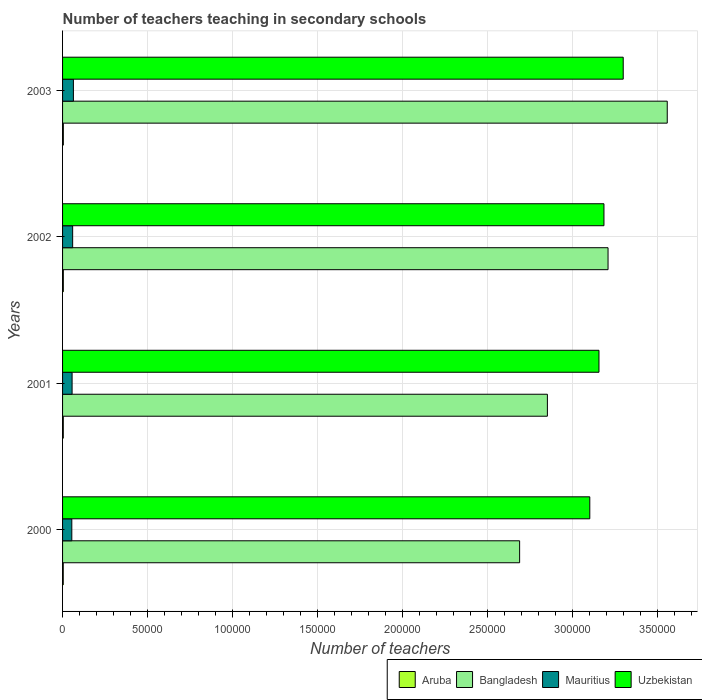How many different coloured bars are there?
Offer a terse response. 4. What is the number of teachers teaching in secondary schools in Bangladesh in 2001?
Offer a very short reply. 2.85e+05. Across all years, what is the maximum number of teachers teaching in secondary schools in Uzbekistan?
Make the answer very short. 3.30e+05. Across all years, what is the minimum number of teachers teaching in secondary schools in Bangladesh?
Your response must be concise. 2.69e+05. What is the total number of teachers teaching in secondary schools in Mauritius in the graph?
Provide a succinct answer. 2.33e+04. What is the difference between the number of teachers teaching in secondary schools in Mauritius in 2000 and that in 2001?
Keep it short and to the point. -171. What is the difference between the number of teachers teaching in secondary schools in Mauritius in 2000 and the number of teachers teaching in secondary schools in Uzbekistan in 2001?
Your response must be concise. -3.10e+05. What is the average number of teachers teaching in secondary schools in Bangladesh per year?
Make the answer very short. 3.08e+05. In the year 2002, what is the difference between the number of teachers teaching in secondary schools in Uzbekistan and number of teachers teaching in secondary schools in Bangladesh?
Provide a succinct answer. -2413. What is the ratio of the number of teachers teaching in secondary schools in Bangladesh in 2000 to that in 2003?
Provide a short and direct response. 0.76. What is the difference between the highest and the second highest number of teachers teaching in secondary schools in Uzbekistan?
Your answer should be compact. 1.13e+04. What is the difference between the highest and the lowest number of teachers teaching in secondary schools in Mauritius?
Offer a terse response. 935. In how many years, is the number of teachers teaching in secondary schools in Mauritius greater than the average number of teachers teaching in secondary schools in Mauritius taken over all years?
Offer a very short reply. 2. Is the sum of the number of teachers teaching in secondary schools in Aruba in 2000 and 2001 greater than the maximum number of teachers teaching in secondary schools in Bangladesh across all years?
Offer a very short reply. No. Is it the case that in every year, the sum of the number of teachers teaching in secondary schools in Bangladesh and number of teachers teaching in secondary schools in Aruba is greater than the sum of number of teachers teaching in secondary schools in Mauritius and number of teachers teaching in secondary schools in Uzbekistan?
Provide a short and direct response. No. What does the 1st bar from the top in 2002 represents?
Your response must be concise. Uzbekistan. What does the 2nd bar from the bottom in 2000 represents?
Provide a succinct answer. Bangladesh. How many years are there in the graph?
Give a very brief answer. 4. What is the difference between two consecutive major ticks on the X-axis?
Keep it short and to the point. 5.00e+04. Are the values on the major ticks of X-axis written in scientific E-notation?
Offer a very short reply. No. Where does the legend appear in the graph?
Provide a succinct answer. Bottom right. What is the title of the graph?
Give a very brief answer. Number of teachers teaching in secondary schools. What is the label or title of the X-axis?
Your answer should be compact. Number of teachers. What is the Number of teachers in Aruba in 2000?
Offer a very short reply. 405. What is the Number of teachers in Bangladesh in 2000?
Make the answer very short. 2.69e+05. What is the Number of teachers in Mauritius in 2000?
Your answer should be very brief. 5436. What is the Number of teachers in Uzbekistan in 2000?
Your answer should be compact. 3.10e+05. What is the Number of teachers of Aruba in 2001?
Keep it short and to the point. 427. What is the Number of teachers of Bangladesh in 2001?
Offer a very short reply. 2.85e+05. What is the Number of teachers of Mauritius in 2001?
Keep it short and to the point. 5607. What is the Number of teachers in Uzbekistan in 2001?
Provide a succinct answer. 3.15e+05. What is the Number of teachers in Aruba in 2002?
Your response must be concise. 449. What is the Number of teachers in Bangladesh in 2002?
Provide a succinct answer. 3.21e+05. What is the Number of teachers of Mauritius in 2002?
Make the answer very short. 5933. What is the Number of teachers in Uzbekistan in 2002?
Make the answer very short. 3.18e+05. What is the Number of teachers in Aruba in 2003?
Offer a very short reply. 461. What is the Number of teachers of Bangladesh in 2003?
Your response must be concise. 3.56e+05. What is the Number of teachers of Mauritius in 2003?
Offer a very short reply. 6371. What is the Number of teachers of Uzbekistan in 2003?
Your answer should be very brief. 3.30e+05. Across all years, what is the maximum Number of teachers of Aruba?
Offer a very short reply. 461. Across all years, what is the maximum Number of teachers in Bangladesh?
Your answer should be very brief. 3.56e+05. Across all years, what is the maximum Number of teachers of Mauritius?
Give a very brief answer. 6371. Across all years, what is the maximum Number of teachers in Uzbekistan?
Keep it short and to the point. 3.30e+05. Across all years, what is the minimum Number of teachers of Aruba?
Offer a terse response. 405. Across all years, what is the minimum Number of teachers of Bangladesh?
Your answer should be compact. 2.69e+05. Across all years, what is the minimum Number of teachers of Mauritius?
Offer a terse response. 5436. Across all years, what is the minimum Number of teachers in Uzbekistan?
Make the answer very short. 3.10e+05. What is the total Number of teachers of Aruba in the graph?
Ensure brevity in your answer.  1742. What is the total Number of teachers of Bangladesh in the graph?
Keep it short and to the point. 1.23e+06. What is the total Number of teachers of Mauritius in the graph?
Ensure brevity in your answer.  2.33e+04. What is the total Number of teachers in Uzbekistan in the graph?
Ensure brevity in your answer.  1.27e+06. What is the difference between the Number of teachers of Aruba in 2000 and that in 2001?
Offer a terse response. -22. What is the difference between the Number of teachers in Bangladesh in 2000 and that in 2001?
Offer a very short reply. -1.63e+04. What is the difference between the Number of teachers in Mauritius in 2000 and that in 2001?
Your answer should be very brief. -171. What is the difference between the Number of teachers in Uzbekistan in 2000 and that in 2001?
Ensure brevity in your answer.  -5396. What is the difference between the Number of teachers in Aruba in 2000 and that in 2002?
Your response must be concise. -44. What is the difference between the Number of teachers of Bangladesh in 2000 and that in 2002?
Provide a succinct answer. -5.20e+04. What is the difference between the Number of teachers in Mauritius in 2000 and that in 2002?
Offer a very short reply. -497. What is the difference between the Number of teachers of Uzbekistan in 2000 and that in 2002?
Your answer should be compact. -8323. What is the difference between the Number of teachers of Aruba in 2000 and that in 2003?
Give a very brief answer. -56. What is the difference between the Number of teachers of Bangladesh in 2000 and that in 2003?
Your answer should be compact. -8.68e+04. What is the difference between the Number of teachers of Mauritius in 2000 and that in 2003?
Provide a succinct answer. -935. What is the difference between the Number of teachers in Uzbekistan in 2000 and that in 2003?
Ensure brevity in your answer.  -1.96e+04. What is the difference between the Number of teachers of Bangladesh in 2001 and that in 2002?
Give a very brief answer. -3.57e+04. What is the difference between the Number of teachers of Mauritius in 2001 and that in 2002?
Provide a succinct answer. -326. What is the difference between the Number of teachers in Uzbekistan in 2001 and that in 2002?
Keep it short and to the point. -2927. What is the difference between the Number of teachers of Aruba in 2001 and that in 2003?
Provide a short and direct response. -34. What is the difference between the Number of teachers of Bangladesh in 2001 and that in 2003?
Ensure brevity in your answer.  -7.05e+04. What is the difference between the Number of teachers of Mauritius in 2001 and that in 2003?
Ensure brevity in your answer.  -764. What is the difference between the Number of teachers of Uzbekistan in 2001 and that in 2003?
Offer a very short reply. -1.43e+04. What is the difference between the Number of teachers of Bangladesh in 2002 and that in 2003?
Your answer should be compact. -3.48e+04. What is the difference between the Number of teachers of Mauritius in 2002 and that in 2003?
Offer a terse response. -438. What is the difference between the Number of teachers in Uzbekistan in 2002 and that in 2003?
Provide a short and direct response. -1.13e+04. What is the difference between the Number of teachers of Aruba in 2000 and the Number of teachers of Bangladesh in 2001?
Provide a succinct answer. -2.85e+05. What is the difference between the Number of teachers of Aruba in 2000 and the Number of teachers of Mauritius in 2001?
Give a very brief answer. -5202. What is the difference between the Number of teachers in Aruba in 2000 and the Number of teachers in Uzbekistan in 2001?
Offer a terse response. -3.15e+05. What is the difference between the Number of teachers in Bangladesh in 2000 and the Number of teachers in Mauritius in 2001?
Make the answer very short. 2.63e+05. What is the difference between the Number of teachers in Bangladesh in 2000 and the Number of teachers in Uzbekistan in 2001?
Give a very brief answer. -4.67e+04. What is the difference between the Number of teachers of Mauritius in 2000 and the Number of teachers of Uzbekistan in 2001?
Give a very brief answer. -3.10e+05. What is the difference between the Number of teachers in Aruba in 2000 and the Number of teachers in Bangladesh in 2002?
Provide a short and direct response. -3.20e+05. What is the difference between the Number of teachers of Aruba in 2000 and the Number of teachers of Mauritius in 2002?
Your answer should be compact. -5528. What is the difference between the Number of teachers of Aruba in 2000 and the Number of teachers of Uzbekistan in 2002?
Your response must be concise. -3.18e+05. What is the difference between the Number of teachers in Bangladesh in 2000 and the Number of teachers in Mauritius in 2002?
Keep it short and to the point. 2.63e+05. What is the difference between the Number of teachers in Bangladesh in 2000 and the Number of teachers in Uzbekistan in 2002?
Your answer should be compact. -4.96e+04. What is the difference between the Number of teachers in Mauritius in 2000 and the Number of teachers in Uzbekistan in 2002?
Provide a short and direct response. -3.13e+05. What is the difference between the Number of teachers of Aruba in 2000 and the Number of teachers of Bangladesh in 2003?
Ensure brevity in your answer.  -3.55e+05. What is the difference between the Number of teachers in Aruba in 2000 and the Number of teachers in Mauritius in 2003?
Provide a succinct answer. -5966. What is the difference between the Number of teachers in Aruba in 2000 and the Number of teachers in Uzbekistan in 2003?
Your answer should be compact. -3.29e+05. What is the difference between the Number of teachers in Bangladesh in 2000 and the Number of teachers in Mauritius in 2003?
Ensure brevity in your answer.  2.62e+05. What is the difference between the Number of teachers in Bangladesh in 2000 and the Number of teachers in Uzbekistan in 2003?
Your answer should be very brief. -6.09e+04. What is the difference between the Number of teachers in Mauritius in 2000 and the Number of teachers in Uzbekistan in 2003?
Provide a succinct answer. -3.24e+05. What is the difference between the Number of teachers in Aruba in 2001 and the Number of teachers in Bangladesh in 2002?
Ensure brevity in your answer.  -3.20e+05. What is the difference between the Number of teachers of Aruba in 2001 and the Number of teachers of Mauritius in 2002?
Ensure brevity in your answer.  -5506. What is the difference between the Number of teachers in Aruba in 2001 and the Number of teachers in Uzbekistan in 2002?
Provide a succinct answer. -3.18e+05. What is the difference between the Number of teachers of Bangladesh in 2001 and the Number of teachers of Mauritius in 2002?
Give a very brief answer. 2.79e+05. What is the difference between the Number of teachers of Bangladesh in 2001 and the Number of teachers of Uzbekistan in 2002?
Keep it short and to the point. -3.33e+04. What is the difference between the Number of teachers in Mauritius in 2001 and the Number of teachers in Uzbekistan in 2002?
Make the answer very short. -3.13e+05. What is the difference between the Number of teachers of Aruba in 2001 and the Number of teachers of Bangladesh in 2003?
Give a very brief answer. -3.55e+05. What is the difference between the Number of teachers in Aruba in 2001 and the Number of teachers in Mauritius in 2003?
Your answer should be very brief. -5944. What is the difference between the Number of teachers in Aruba in 2001 and the Number of teachers in Uzbekistan in 2003?
Provide a succinct answer. -3.29e+05. What is the difference between the Number of teachers of Bangladesh in 2001 and the Number of teachers of Mauritius in 2003?
Provide a short and direct response. 2.79e+05. What is the difference between the Number of teachers of Bangladesh in 2001 and the Number of teachers of Uzbekistan in 2003?
Provide a succinct answer. -4.46e+04. What is the difference between the Number of teachers in Mauritius in 2001 and the Number of teachers in Uzbekistan in 2003?
Your answer should be compact. -3.24e+05. What is the difference between the Number of teachers in Aruba in 2002 and the Number of teachers in Bangladesh in 2003?
Ensure brevity in your answer.  -3.55e+05. What is the difference between the Number of teachers in Aruba in 2002 and the Number of teachers in Mauritius in 2003?
Provide a succinct answer. -5922. What is the difference between the Number of teachers of Aruba in 2002 and the Number of teachers of Uzbekistan in 2003?
Offer a terse response. -3.29e+05. What is the difference between the Number of teachers of Bangladesh in 2002 and the Number of teachers of Mauritius in 2003?
Provide a succinct answer. 3.14e+05. What is the difference between the Number of teachers of Bangladesh in 2002 and the Number of teachers of Uzbekistan in 2003?
Ensure brevity in your answer.  -8913. What is the difference between the Number of teachers in Mauritius in 2002 and the Number of teachers in Uzbekistan in 2003?
Your answer should be compact. -3.24e+05. What is the average Number of teachers in Aruba per year?
Make the answer very short. 435.5. What is the average Number of teachers of Bangladesh per year?
Give a very brief answer. 3.08e+05. What is the average Number of teachers in Mauritius per year?
Offer a very short reply. 5836.75. What is the average Number of teachers of Uzbekistan per year?
Your response must be concise. 3.18e+05. In the year 2000, what is the difference between the Number of teachers of Aruba and Number of teachers of Bangladesh?
Offer a very short reply. -2.68e+05. In the year 2000, what is the difference between the Number of teachers in Aruba and Number of teachers in Mauritius?
Your answer should be very brief. -5031. In the year 2000, what is the difference between the Number of teachers of Aruba and Number of teachers of Uzbekistan?
Offer a terse response. -3.10e+05. In the year 2000, what is the difference between the Number of teachers in Bangladesh and Number of teachers in Mauritius?
Offer a terse response. 2.63e+05. In the year 2000, what is the difference between the Number of teachers of Bangladesh and Number of teachers of Uzbekistan?
Keep it short and to the point. -4.13e+04. In the year 2000, what is the difference between the Number of teachers in Mauritius and Number of teachers in Uzbekistan?
Ensure brevity in your answer.  -3.05e+05. In the year 2001, what is the difference between the Number of teachers of Aruba and Number of teachers of Bangladesh?
Your response must be concise. -2.85e+05. In the year 2001, what is the difference between the Number of teachers of Aruba and Number of teachers of Mauritius?
Provide a succinct answer. -5180. In the year 2001, what is the difference between the Number of teachers in Aruba and Number of teachers in Uzbekistan?
Ensure brevity in your answer.  -3.15e+05. In the year 2001, what is the difference between the Number of teachers of Bangladesh and Number of teachers of Mauritius?
Your answer should be very brief. 2.80e+05. In the year 2001, what is the difference between the Number of teachers in Bangladesh and Number of teachers in Uzbekistan?
Your response must be concise. -3.03e+04. In the year 2001, what is the difference between the Number of teachers in Mauritius and Number of teachers in Uzbekistan?
Provide a succinct answer. -3.10e+05. In the year 2002, what is the difference between the Number of teachers of Aruba and Number of teachers of Bangladesh?
Your response must be concise. -3.20e+05. In the year 2002, what is the difference between the Number of teachers of Aruba and Number of teachers of Mauritius?
Provide a succinct answer. -5484. In the year 2002, what is the difference between the Number of teachers in Aruba and Number of teachers in Uzbekistan?
Keep it short and to the point. -3.18e+05. In the year 2002, what is the difference between the Number of teachers of Bangladesh and Number of teachers of Mauritius?
Your response must be concise. 3.15e+05. In the year 2002, what is the difference between the Number of teachers of Bangladesh and Number of teachers of Uzbekistan?
Ensure brevity in your answer.  2413. In the year 2002, what is the difference between the Number of teachers in Mauritius and Number of teachers in Uzbekistan?
Your response must be concise. -3.12e+05. In the year 2003, what is the difference between the Number of teachers of Aruba and Number of teachers of Bangladesh?
Offer a very short reply. -3.55e+05. In the year 2003, what is the difference between the Number of teachers of Aruba and Number of teachers of Mauritius?
Make the answer very short. -5910. In the year 2003, what is the difference between the Number of teachers in Aruba and Number of teachers in Uzbekistan?
Make the answer very short. -3.29e+05. In the year 2003, what is the difference between the Number of teachers of Bangladesh and Number of teachers of Mauritius?
Provide a short and direct response. 3.49e+05. In the year 2003, what is the difference between the Number of teachers of Bangladesh and Number of teachers of Uzbekistan?
Offer a very short reply. 2.59e+04. In the year 2003, what is the difference between the Number of teachers of Mauritius and Number of teachers of Uzbekistan?
Your answer should be very brief. -3.23e+05. What is the ratio of the Number of teachers of Aruba in 2000 to that in 2001?
Your response must be concise. 0.95. What is the ratio of the Number of teachers of Bangladesh in 2000 to that in 2001?
Provide a succinct answer. 0.94. What is the ratio of the Number of teachers in Mauritius in 2000 to that in 2001?
Your answer should be very brief. 0.97. What is the ratio of the Number of teachers in Uzbekistan in 2000 to that in 2001?
Make the answer very short. 0.98. What is the ratio of the Number of teachers in Aruba in 2000 to that in 2002?
Provide a succinct answer. 0.9. What is the ratio of the Number of teachers of Bangladesh in 2000 to that in 2002?
Provide a succinct answer. 0.84. What is the ratio of the Number of teachers of Mauritius in 2000 to that in 2002?
Offer a terse response. 0.92. What is the ratio of the Number of teachers of Uzbekistan in 2000 to that in 2002?
Ensure brevity in your answer.  0.97. What is the ratio of the Number of teachers of Aruba in 2000 to that in 2003?
Give a very brief answer. 0.88. What is the ratio of the Number of teachers of Bangladesh in 2000 to that in 2003?
Provide a succinct answer. 0.76. What is the ratio of the Number of teachers in Mauritius in 2000 to that in 2003?
Your answer should be compact. 0.85. What is the ratio of the Number of teachers in Uzbekistan in 2000 to that in 2003?
Make the answer very short. 0.94. What is the ratio of the Number of teachers of Aruba in 2001 to that in 2002?
Keep it short and to the point. 0.95. What is the ratio of the Number of teachers of Bangladesh in 2001 to that in 2002?
Keep it short and to the point. 0.89. What is the ratio of the Number of teachers of Mauritius in 2001 to that in 2002?
Provide a short and direct response. 0.95. What is the ratio of the Number of teachers of Aruba in 2001 to that in 2003?
Your response must be concise. 0.93. What is the ratio of the Number of teachers of Bangladesh in 2001 to that in 2003?
Your response must be concise. 0.8. What is the ratio of the Number of teachers in Mauritius in 2001 to that in 2003?
Your answer should be very brief. 0.88. What is the ratio of the Number of teachers in Uzbekistan in 2001 to that in 2003?
Give a very brief answer. 0.96. What is the ratio of the Number of teachers of Aruba in 2002 to that in 2003?
Offer a terse response. 0.97. What is the ratio of the Number of teachers in Bangladesh in 2002 to that in 2003?
Provide a short and direct response. 0.9. What is the ratio of the Number of teachers of Mauritius in 2002 to that in 2003?
Your answer should be very brief. 0.93. What is the ratio of the Number of teachers of Uzbekistan in 2002 to that in 2003?
Give a very brief answer. 0.97. What is the difference between the highest and the second highest Number of teachers in Aruba?
Provide a succinct answer. 12. What is the difference between the highest and the second highest Number of teachers in Bangladesh?
Your answer should be compact. 3.48e+04. What is the difference between the highest and the second highest Number of teachers of Mauritius?
Give a very brief answer. 438. What is the difference between the highest and the second highest Number of teachers in Uzbekistan?
Your response must be concise. 1.13e+04. What is the difference between the highest and the lowest Number of teachers in Aruba?
Give a very brief answer. 56. What is the difference between the highest and the lowest Number of teachers of Bangladesh?
Keep it short and to the point. 8.68e+04. What is the difference between the highest and the lowest Number of teachers of Mauritius?
Your answer should be compact. 935. What is the difference between the highest and the lowest Number of teachers in Uzbekistan?
Offer a terse response. 1.96e+04. 